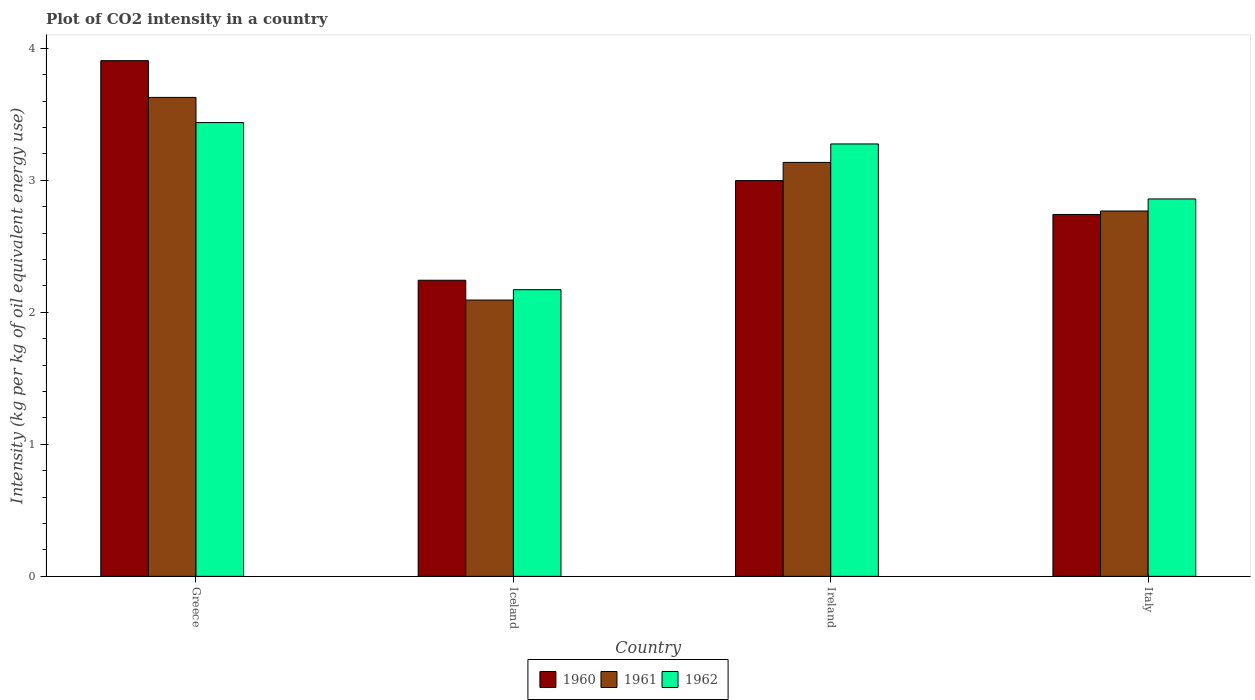How many groups of bars are there?
Provide a succinct answer. 4. Are the number of bars on each tick of the X-axis equal?
Provide a succinct answer. Yes. How many bars are there on the 1st tick from the left?
Ensure brevity in your answer.  3. How many bars are there on the 1st tick from the right?
Provide a short and direct response. 3. What is the label of the 3rd group of bars from the left?
Ensure brevity in your answer.  Ireland. What is the CO2 intensity in in 1961 in Iceland?
Your answer should be compact. 2.09. Across all countries, what is the maximum CO2 intensity in in 1962?
Make the answer very short. 3.44. Across all countries, what is the minimum CO2 intensity in in 1960?
Your response must be concise. 2.24. What is the total CO2 intensity in in 1960 in the graph?
Give a very brief answer. 11.89. What is the difference between the CO2 intensity in in 1962 in Greece and that in Ireland?
Make the answer very short. 0.16. What is the difference between the CO2 intensity in in 1960 in Ireland and the CO2 intensity in in 1962 in Greece?
Your answer should be compact. -0.44. What is the average CO2 intensity in in 1960 per country?
Offer a terse response. 2.97. What is the difference between the CO2 intensity in of/in 1961 and CO2 intensity in of/in 1960 in Italy?
Ensure brevity in your answer.  0.03. In how many countries, is the CO2 intensity in in 1961 greater than 1.4 kg?
Give a very brief answer. 4. What is the ratio of the CO2 intensity in in 1961 in Greece to that in Italy?
Your answer should be compact. 1.31. Is the difference between the CO2 intensity in in 1961 in Ireland and Italy greater than the difference between the CO2 intensity in in 1960 in Ireland and Italy?
Your response must be concise. Yes. What is the difference between the highest and the second highest CO2 intensity in in 1961?
Ensure brevity in your answer.  0.37. What is the difference between the highest and the lowest CO2 intensity in in 1960?
Provide a succinct answer. 1.66. In how many countries, is the CO2 intensity in in 1961 greater than the average CO2 intensity in in 1961 taken over all countries?
Offer a terse response. 2. Is the sum of the CO2 intensity in in 1961 in Ireland and Italy greater than the maximum CO2 intensity in in 1962 across all countries?
Make the answer very short. Yes. What does the 1st bar from the left in Iceland represents?
Offer a terse response. 1960. How many bars are there?
Offer a very short reply. 12. What is the difference between two consecutive major ticks on the Y-axis?
Offer a terse response. 1. Are the values on the major ticks of Y-axis written in scientific E-notation?
Provide a succinct answer. No. Does the graph contain grids?
Offer a terse response. No. Where does the legend appear in the graph?
Offer a very short reply. Bottom center. What is the title of the graph?
Your response must be concise. Plot of CO2 intensity in a country. What is the label or title of the X-axis?
Give a very brief answer. Country. What is the label or title of the Y-axis?
Provide a short and direct response. Intensity (kg per kg of oil equivalent energy use). What is the Intensity (kg per kg of oil equivalent energy use) in 1960 in Greece?
Keep it short and to the point. 3.91. What is the Intensity (kg per kg of oil equivalent energy use) in 1961 in Greece?
Your answer should be compact. 3.63. What is the Intensity (kg per kg of oil equivalent energy use) of 1962 in Greece?
Your response must be concise. 3.44. What is the Intensity (kg per kg of oil equivalent energy use) of 1960 in Iceland?
Your answer should be very brief. 2.24. What is the Intensity (kg per kg of oil equivalent energy use) of 1961 in Iceland?
Ensure brevity in your answer.  2.09. What is the Intensity (kg per kg of oil equivalent energy use) of 1962 in Iceland?
Provide a short and direct response. 2.17. What is the Intensity (kg per kg of oil equivalent energy use) of 1960 in Ireland?
Provide a short and direct response. 3. What is the Intensity (kg per kg of oil equivalent energy use) of 1961 in Ireland?
Your response must be concise. 3.14. What is the Intensity (kg per kg of oil equivalent energy use) in 1962 in Ireland?
Make the answer very short. 3.27. What is the Intensity (kg per kg of oil equivalent energy use) in 1960 in Italy?
Make the answer very short. 2.74. What is the Intensity (kg per kg of oil equivalent energy use) of 1961 in Italy?
Give a very brief answer. 2.77. What is the Intensity (kg per kg of oil equivalent energy use) in 1962 in Italy?
Offer a terse response. 2.86. Across all countries, what is the maximum Intensity (kg per kg of oil equivalent energy use) in 1960?
Make the answer very short. 3.91. Across all countries, what is the maximum Intensity (kg per kg of oil equivalent energy use) in 1961?
Your answer should be compact. 3.63. Across all countries, what is the maximum Intensity (kg per kg of oil equivalent energy use) in 1962?
Keep it short and to the point. 3.44. Across all countries, what is the minimum Intensity (kg per kg of oil equivalent energy use) in 1960?
Provide a succinct answer. 2.24. Across all countries, what is the minimum Intensity (kg per kg of oil equivalent energy use) in 1961?
Your answer should be compact. 2.09. Across all countries, what is the minimum Intensity (kg per kg of oil equivalent energy use) in 1962?
Ensure brevity in your answer.  2.17. What is the total Intensity (kg per kg of oil equivalent energy use) in 1960 in the graph?
Your answer should be compact. 11.89. What is the total Intensity (kg per kg of oil equivalent energy use) of 1961 in the graph?
Provide a succinct answer. 11.62. What is the total Intensity (kg per kg of oil equivalent energy use) of 1962 in the graph?
Offer a terse response. 11.74. What is the difference between the Intensity (kg per kg of oil equivalent energy use) of 1960 in Greece and that in Iceland?
Provide a short and direct response. 1.66. What is the difference between the Intensity (kg per kg of oil equivalent energy use) in 1961 in Greece and that in Iceland?
Offer a very short reply. 1.53. What is the difference between the Intensity (kg per kg of oil equivalent energy use) in 1962 in Greece and that in Iceland?
Make the answer very short. 1.27. What is the difference between the Intensity (kg per kg of oil equivalent energy use) of 1960 in Greece and that in Ireland?
Offer a very short reply. 0.91. What is the difference between the Intensity (kg per kg of oil equivalent energy use) in 1961 in Greece and that in Ireland?
Your answer should be compact. 0.49. What is the difference between the Intensity (kg per kg of oil equivalent energy use) of 1962 in Greece and that in Ireland?
Make the answer very short. 0.16. What is the difference between the Intensity (kg per kg of oil equivalent energy use) in 1960 in Greece and that in Italy?
Offer a very short reply. 1.16. What is the difference between the Intensity (kg per kg of oil equivalent energy use) in 1961 in Greece and that in Italy?
Keep it short and to the point. 0.86. What is the difference between the Intensity (kg per kg of oil equivalent energy use) in 1962 in Greece and that in Italy?
Give a very brief answer. 0.58. What is the difference between the Intensity (kg per kg of oil equivalent energy use) of 1960 in Iceland and that in Ireland?
Give a very brief answer. -0.75. What is the difference between the Intensity (kg per kg of oil equivalent energy use) in 1961 in Iceland and that in Ireland?
Your answer should be very brief. -1.04. What is the difference between the Intensity (kg per kg of oil equivalent energy use) in 1962 in Iceland and that in Ireland?
Your answer should be very brief. -1.1. What is the difference between the Intensity (kg per kg of oil equivalent energy use) of 1960 in Iceland and that in Italy?
Ensure brevity in your answer.  -0.5. What is the difference between the Intensity (kg per kg of oil equivalent energy use) of 1961 in Iceland and that in Italy?
Provide a short and direct response. -0.67. What is the difference between the Intensity (kg per kg of oil equivalent energy use) of 1962 in Iceland and that in Italy?
Provide a short and direct response. -0.69. What is the difference between the Intensity (kg per kg of oil equivalent energy use) of 1960 in Ireland and that in Italy?
Offer a terse response. 0.26. What is the difference between the Intensity (kg per kg of oil equivalent energy use) in 1961 in Ireland and that in Italy?
Your answer should be very brief. 0.37. What is the difference between the Intensity (kg per kg of oil equivalent energy use) in 1962 in Ireland and that in Italy?
Offer a very short reply. 0.42. What is the difference between the Intensity (kg per kg of oil equivalent energy use) of 1960 in Greece and the Intensity (kg per kg of oil equivalent energy use) of 1961 in Iceland?
Offer a very short reply. 1.81. What is the difference between the Intensity (kg per kg of oil equivalent energy use) of 1960 in Greece and the Intensity (kg per kg of oil equivalent energy use) of 1962 in Iceland?
Make the answer very short. 1.73. What is the difference between the Intensity (kg per kg of oil equivalent energy use) of 1961 in Greece and the Intensity (kg per kg of oil equivalent energy use) of 1962 in Iceland?
Offer a terse response. 1.46. What is the difference between the Intensity (kg per kg of oil equivalent energy use) in 1960 in Greece and the Intensity (kg per kg of oil equivalent energy use) in 1961 in Ireland?
Provide a succinct answer. 0.77. What is the difference between the Intensity (kg per kg of oil equivalent energy use) in 1960 in Greece and the Intensity (kg per kg of oil equivalent energy use) in 1962 in Ireland?
Provide a succinct answer. 0.63. What is the difference between the Intensity (kg per kg of oil equivalent energy use) in 1961 in Greece and the Intensity (kg per kg of oil equivalent energy use) in 1962 in Ireland?
Your answer should be compact. 0.35. What is the difference between the Intensity (kg per kg of oil equivalent energy use) of 1960 in Greece and the Intensity (kg per kg of oil equivalent energy use) of 1961 in Italy?
Keep it short and to the point. 1.14. What is the difference between the Intensity (kg per kg of oil equivalent energy use) in 1960 in Greece and the Intensity (kg per kg of oil equivalent energy use) in 1962 in Italy?
Make the answer very short. 1.05. What is the difference between the Intensity (kg per kg of oil equivalent energy use) of 1961 in Greece and the Intensity (kg per kg of oil equivalent energy use) of 1962 in Italy?
Provide a short and direct response. 0.77. What is the difference between the Intensity (kg per kg of oil equivalent energy use) in 1960 in Iceland and the Intensity (kg per kg of oil equivalent energy use) in 1961 in Ireland?
Your answer should be compact. -0.89. What is the difference between the Intensity (kg per kg of oil equivalent energy use) of 1960 in Iceland and the Intensity (kg per kg of oil equivalent energy use) of 1962 in Ireland?
Offer a very short reply. -1.03. What is the difference between the Intensity (kg per kg of oil equivalent energy use) in 1961 in Iceland and the Intensity (kg per kg of oil equivalent energy use) in 1962 in Ireland?
Your answer should be compact. -1.18. What is the difference between the Intensity (kg per kg of oil equivalent energy use) in 1960 in Iceland and the Intensity (kg per kg of oil equivalent energy use) in 1961 in Italy?
Keep it short and to the point. -0.52. What is the difference between the Intensity (kg per kg of oil equivalent energy use) in 1960 in Iceland and the Intensity (kg per kg of oil equivalent energy use) in 1962 in Italy?
Provide a succinct answer. -0.62. What is the difference between the Intensity (kg per kg of oil equivalent energy use) of 1961 in Iceland and the Intensity (kg per kg of oil equivalent energy use) of 1962 in Italy?
Provide a succinct answer. -0.77. What is the difference between the Intensity (kg per kg of oil equivalent energy use) in 1960 in Ireland and the Intensity (kg per kg of oil equivalent energy use) in 1961 in Italy?
Offer a terse response. 0.23. What is the difference between the Intensity (kg per kg of oil equivalent energy use) of 1960 in Ireland and the Intensity (kg per kg of oil equivalent energy use) of 1962 in Italy?
Your answer should be very brief. 0.14. What is the difference between the Intensity (kg per kg of oil equivalent energy use) in 1961 in Ireland and the Intensity (kg per kg of oil equivalent energy use) in 1962 in Italy?
Ensure brevity in your answer.  0.28. What is the average Intensity (kg per kg of oil equivalent energy use) in 1960 per country?
Provide a short and direct response. 2.97. What is the average Intensity (kg per kg of oil equivalent energy use) of 1961 per country?
Provide a short and direct response. 2.91. What is the average Intensity (kg per kg of oil equivalent energy use) in 1962 per country?
Your response must be concise. 2.94. What is the difference between the Intensity (kg per kg of oil equivalent energy use) in 1960 and Intensity (kg per kg of oil equivalent energy use) in 1961 in Greece?
Make the answer very short. 0.28. What is the difference between the Intensity (kg per kg of oil equivalent energy use) of 1960 and Intensity (kg per kg of oil equivalent energy use) of 1962 in Greece?
Make the answer very short. 0.47. What is the difference between the Intensity (kg per kg of oil equivalent energy use) of 1961 and Intensity (kg per kg of oil equivalent energy use) of 1962 in Greece?
Ensure brevity in your answer.  0.19. What is the difference between the Intensity (kg per kg of oil equivalent energy use) in 1960 and Intensity (kg per kg of oil equivalent energy use) in 1961 in Iceland?
Give a very brief answer. 0.15. What is the difference between the Intensity (kg per kg of oil equivalent energy use) in 1960 and Intensity (kg per kg of oil equivalent energy use) in 1962 in Iceland?
Your answer should be very brief. 0.07. What is the difference between the Intensity (kg per kg of oil equivalent energy use) of 1961 and Intensity (kg per kg of oil equivalent energy use) of 1962 in Iceland?
Keep it short and to the point. -0.08. What is the difference between the Intensity (kg per kg of oil equivalent energy use) in 1960 and Intensity (kg per kg of oil equivalent energy use) in 1961 in Ireland?
Provide a short and direct response. -0.14. What is the difference between the Intensity (kg per kg of oil equivalent energy use) in 1960 and Intensity (kg per kg of oil equivalent energy use) in 1962 in Ireland?
Give a very brief answer. -0.28. What is the difference between the Intensity (kg per kg of oil equivalent energy use) of 1961 and Intensity (kg per kg of oil equivalent energy use) of 1962 in Ireland?
Ensure brevity in your answer.  -0.14. What is the difference between the Intensity (kg per kg of oil equivalent energy use) in 1960 and Intensity (kg per kg of oil equivalent energy use) in 1961 in Italy?
Ensure brevity in your answer.  -0.03. What is the difference between the Intensity (kg per kg of oil equivalent energy use) of 1960 and Intensity (kg per kg of oil equivalent energy use) of 1962 in Italy?
Ensure brevity in your answer.  -0.12. What is the difference between the Intensity (kg per kg of oil equivalent energy use) of 1961 and Intensity (kg per kg of oil equivalent energy use) of 1962 in Italy?
Your answer should be compact. -0.09. What is the ratio of the Intensity (kg per kg of oil equivalent energy use) of 1960 in Greece to that in Iceland?
Your response must be concise. 1.74. What is the ratio of the Intensity (kg per kg of oil equivalent energy use) in 1961 in Greece to that in Iceland?
Offer a very short reply. 1.73. What is the ratio of the Intensity (kg per kg of oil equivalent energy use) in 1962 in Greece to that in Iceland?
Give a very brief answer. 1.58. What is the ratio of the Intensity (kg per kg of oil equivalent energy use) in 1960 in Greece to that in Ireland?
Make the answer very short. 1.3. What is the ratio of the Intensity (kg per kg of oil equivalent energy use) in 1961 in Greece to that in Ireland?
Provide a succinct answer. 1.16. What is the ratio of the Intensity (kg per kg of oil equivalent energy use) of 1962 in Greece to that in Ireland?
Provide a succinct answer. 1.05. What is the ratio of the Intensity (kg per kg of oil equivalent energy use) in 1960 in Greece to that in Italy?
Offer a terse response. 1.43. What is the ratio of the Intensity (kg per kg of oil equivalent energy use) in 1961 in Greece to that in Italy?
Your answer should be very brief. 1.31. What is the ratio of the Intensity (kg per kg of oil equivalent energy use) of 1962 in Greece to that in Italy?
Provide a short and direct response. 1.2. What is the ratio of the Intensity (kg per kg of oil equivalent energy use) in 1960 in Iceland to that in Ireland?
Ensure brevity in your answer.  0.75. What is the ratio of the Intensity (kg per kg of oil equivalent energy use) of 1961 in Iceland to that in Ireland?
Make the answer very short. 0.67. What is the ratio of the Intensity (kg per kg of oil equivalent energy use) of 1962 in Iceland to that in Ireland?
Ensure brevity in your answer.  0.66. What is the ratio of the Intensity (kg per kg of oil equivalent energy use) in 1960 in Iceland to that in Italy?
Ensure brevity in your answer.  0.82. What is the ratio of the Intensity (kg per kg of oil equivalent energy use) in 1961 in Iceland to that in Italy?
Ensure brevity in your answer.  0.76. What is the ratio of the Intensity (kg per kg of oil equivalent energy use) in 1962 in Iceland to that in Italy?
Your response must be concise. 0.76. What is the ratio of the Intensity (kg per kg of oil equivalent energy use) in 1960 in Ireland to that in Italy?
Offer a terse response. 1.09. What is the ratio of the Intensity (kg per kg of oil equivalent energy use) of 1961 in Ireland to that in Italy?
Offer a very short reply. 1.13. What is the ratio of the Intensity (kg per kg of oil equivalent energy use) in 1962 in Ireland to that in Italy?
Ensure brevity in your answer.  1.15. What is the difference between the highest and the second highest Intensity (kg per kg of oil equivalent energy use) of 1960?
Offer a very short reply. 0.91. What is the difference between the highest and the second highest Intensity (kg per kg of oil equivalent energy use) in 1961?
Your response must be concise. 0.49. What is the difference between the highest and the second highest Intensity (kg per kg of oil equivalent energy use) of 1962?
Provide a succinct answer. 0.16. What is the difference between the highest and the lowest Intensity (kg per kg of oil equivalent energy use) in 1960?
Your response must be concise. 1.66. What is the difference between the highest and the lowest Intensity (kg per kg of oil equivalent energy use) in 1961?
Give a very brief answer. 1.53. What is the difference between the highest and the lowest Intensity (kg per kg of oil equivalent energy use) of 1962?
Provide a short and direct response. 1.27. 